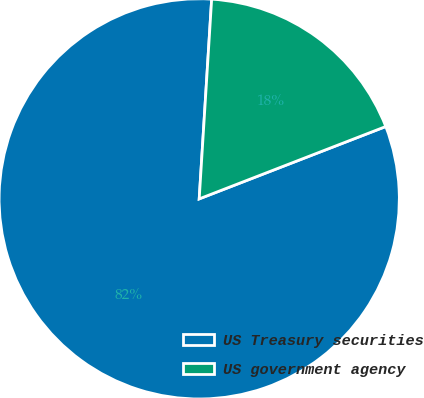Convert chart to OTSL. <chart><loc_0><loc_0><loc_500><loc_500><pie_chart><fcel>US Treasury securities<fcel>US government agency<nl><fcel>81.88%<fcel>18.12%<nl></chart> 